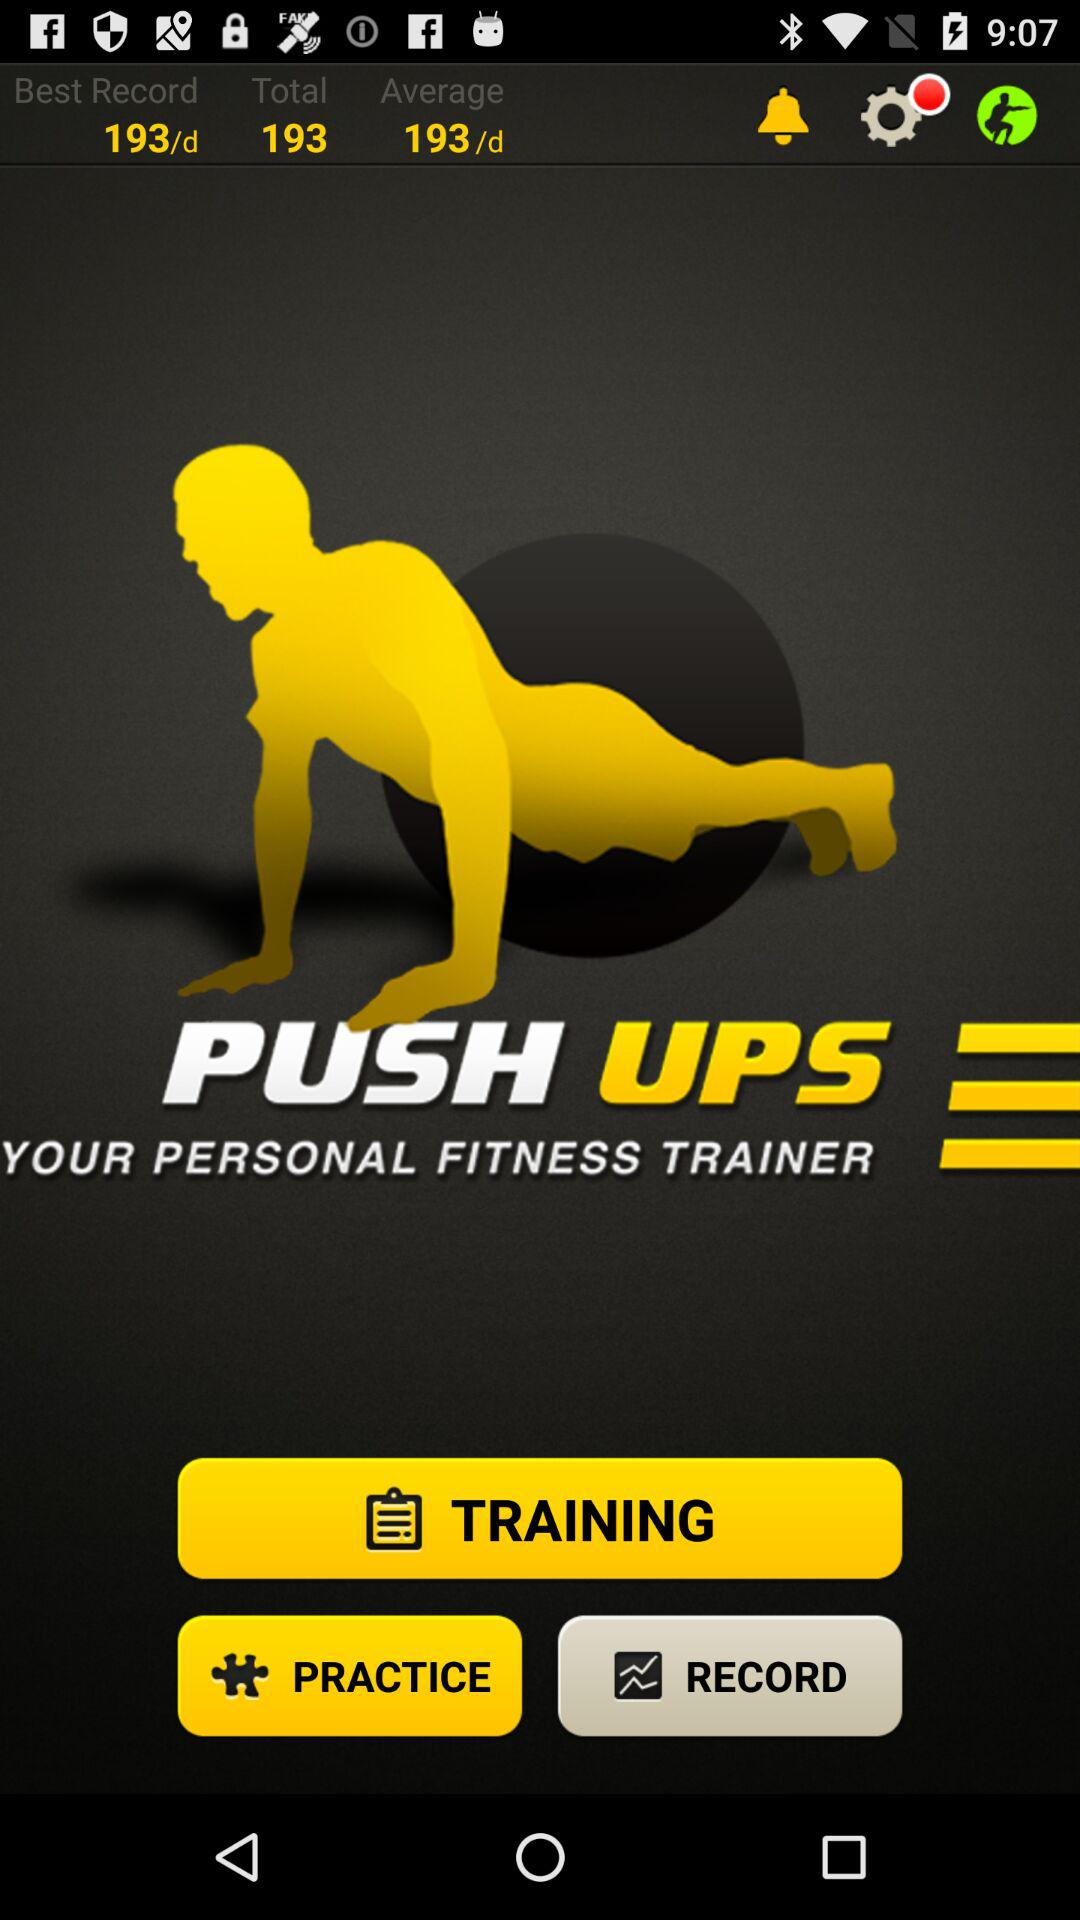What is my average number of push ups per day?
Answer the question using a single word or phrase. 193/d 